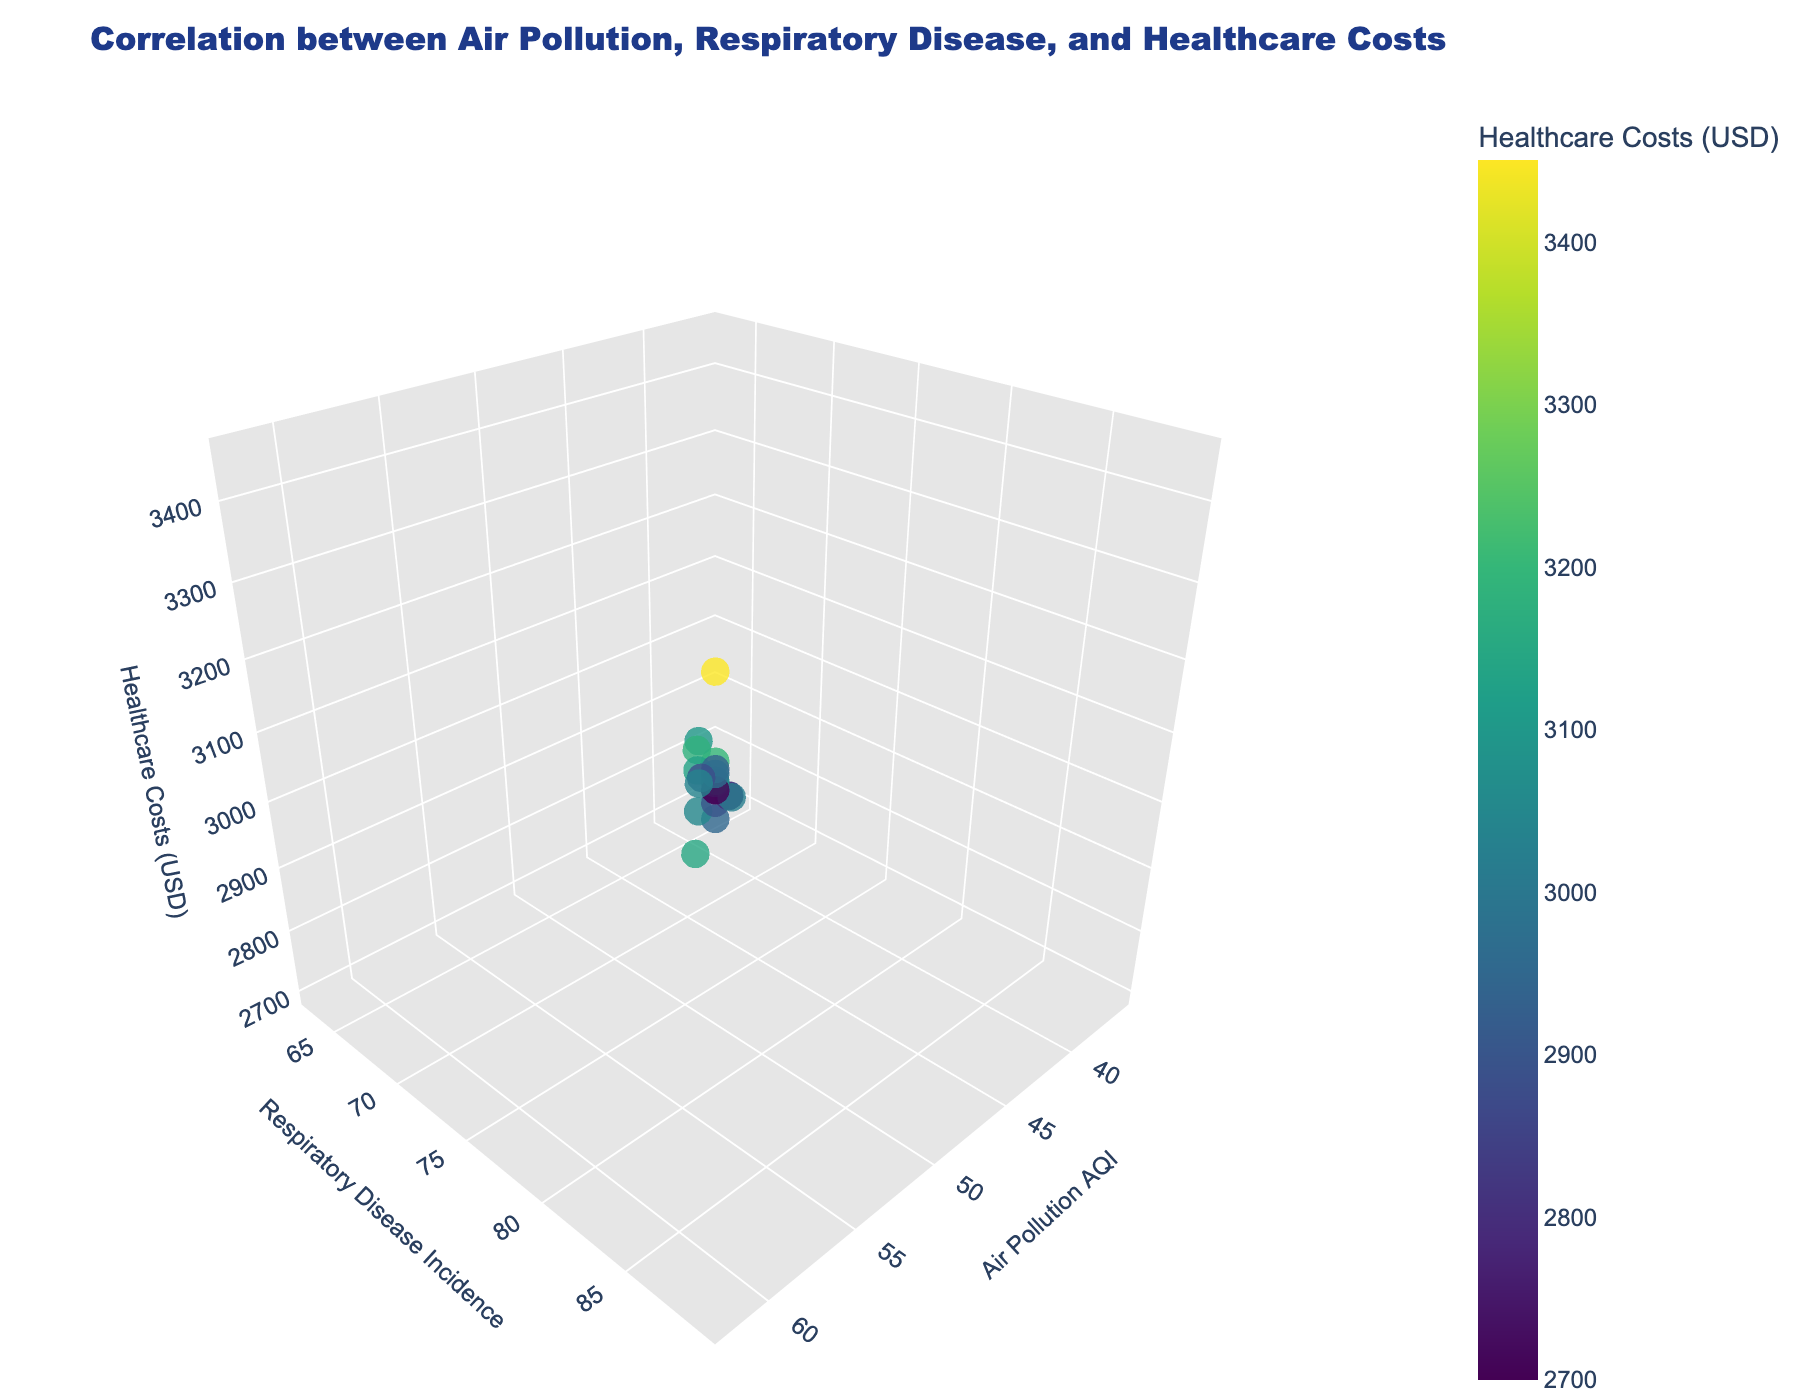What does the title of the figure indicate? The title of the figure indicates that it is analyzing the correlation between air pollution levels, respiratory disease incidence, and healthcare costs across urban areas.
Answer: Correlation between Air Pollution, Respiratory Disease, and Healthcare Costs How many cities are represented in the plot? The plot has one marker representing each city. Counting the number of markers gives the number of cities.
Answer: 19 Which city has the highest air pollution AQI? Look for the point at the farthest right on the x-axis. The hover text will help identify the city. Los Angeles has the highest AQI value of 62.
Answer: Los Angeles What city shows the lowest incidence of respiratory disease? Find the lowest value on the y-axis and use hover text to identify the city. San Francisco has the lowest respiratory disease incidence at 65.
Answer: San Francisco Which two cities have similar healthcare costs but different air pollution AQI values? Compare markers with close z-axis values (healthcare costs) and check their x-axis (air pollution AQI) values. Dallas (AQI 54, Costs $3180) and San Jose (AQI 40, Costs $2800) have similar healthcare costs but different AQI values.
Answer: Dallas and San Jose What's the average healthcare cost among all the cities? Add healthcare costs for all cities and divide by the number of cities: (3200+3450+2950+3150+3050+3100+2900+2850+3180+2800+3130+2750+2980+3020+3080+2700+2930+2970+2880)/19 = 3000.
Answer: 3000 Do cities with higher air pollution always have higher respiratory disease incidence? Examine the correlation between x-axis and y-axis values. Although higher air pollution tends to lead to higher respiratory disease incidence, it's not strictly true for all cities.
Answer: No Which city has the highest healthcare costs, and what are its corresponding air pollution AQI and respiratory disease incidence values? Find the highest z-axis value and check its corresponding x and y values via the hover text. Los Angeles has the highest healthcare costs ($3450), an AQI of 62, and respiratory disease incidence of 89.
Answer: Los Angeles, AQI 62, Incidence 89 Are there any cities with low air pollution but high healthcare costs? Look for points on the left side of the x-axis but at higher values of the z-axis. There are no such cities; all cities with low AQI also have relatively lower healthcare costs.
Answer: No Which city has the lowest healthcare costs, and what are its air pollution AQI and respiratory disease incidence values? Locate the point with the lowest z-axis value and read the hover text. San Francisco has the lowest healthcare costs ($2750), an AQI of 38, and respiratory disease incidence of 65.
Answer: San Francisco, AQI 38, Incidence 65 